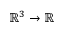<formula> <loc_0><loc_0><loc_500><loc_500>\mathbb { R } ^ { 3 } \to \mathbb { R }</formula> 